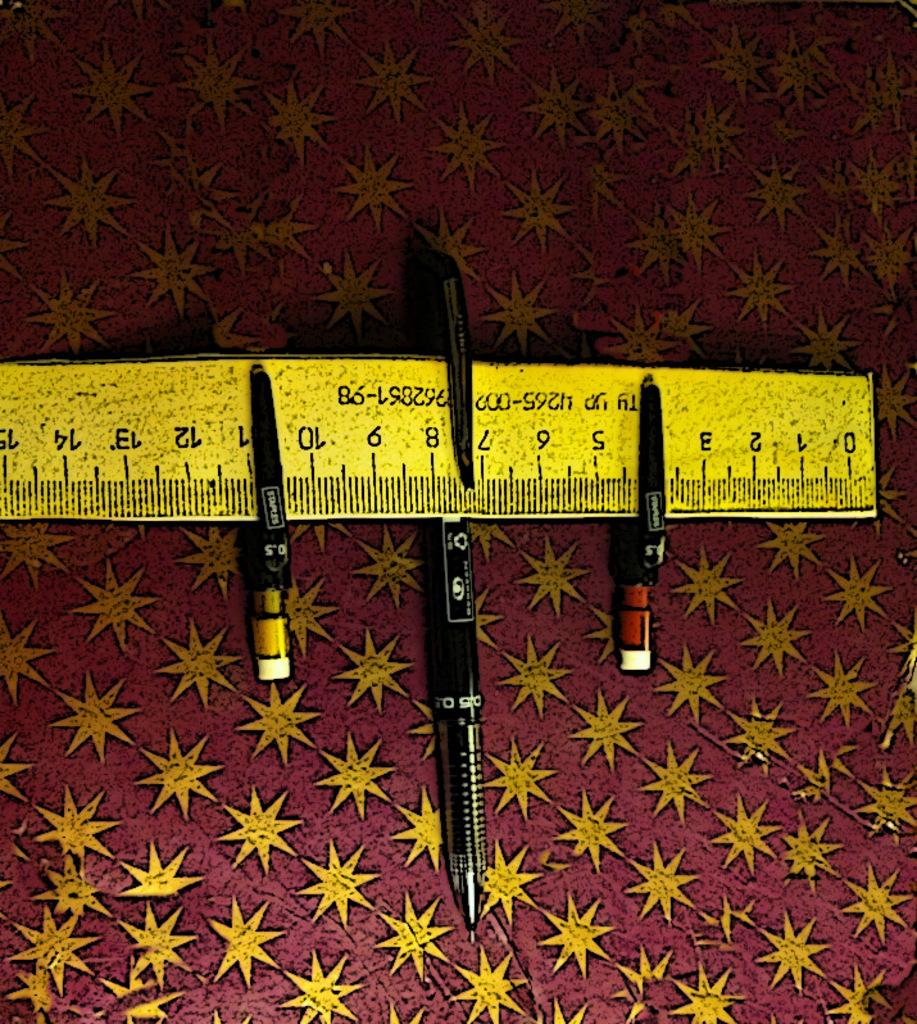<image>
Write a terse but informative summary of the picture. Three pens are attached to a ruler, one of them at the 4 cm mark. 